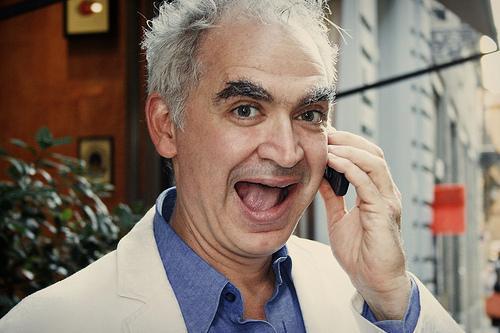How many plants are in this picture?
Give a very brief answer. 1. How many people are pictured here?
Give a very brief answer. 1. 